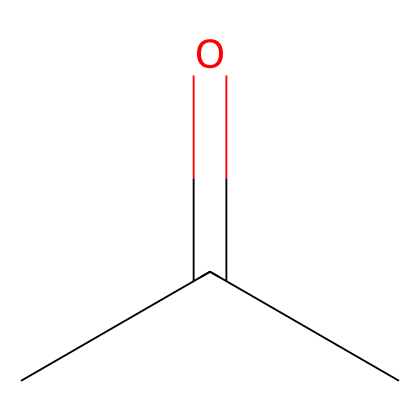What is the name of this chemical? The structure corresponds to acetone, which is the common name for 2-propanone based on its molecular structure.
Answer: acetone How many carbon atoms are in acetone? The SMILES representation indicates three carbon atoms (C), found in the formula structure CC(=O)C. Each 'C' represents a carbon atom.
Answer: 3 What type of functional group is present in acetone? In the given structure, the presence of the carbonyl group (C=O) indicates that this chemical is a ketone. The C=O is the defining feature of ketones.
Answer: ketone What is the total number of hydrogen atoms in acetone? The structure shows that acetone has six hydrogen atoms in total. Each terminal carbon can bond to three hydrogen atoms while the central carbon bonds to one.
Answer: 6 Is acetone polar or nonpolar? The presence of the polar carbonyl group contributes to acetone’s overall polarity, but the symmetrical structure results in a moderate level of polarity.
Answer: polar What is a common use of acetone? Acetone is commonly used as a solvent in various applications, particularly in the production of plastics and nail polish removers.
Answer: solvent What is the molecular formula of acetone? The molecular composition can be deduced from the chemical structure, resulting in the formula C3H6O which corresponds to the arrangement of its atoms.
Answer: C3H6O 